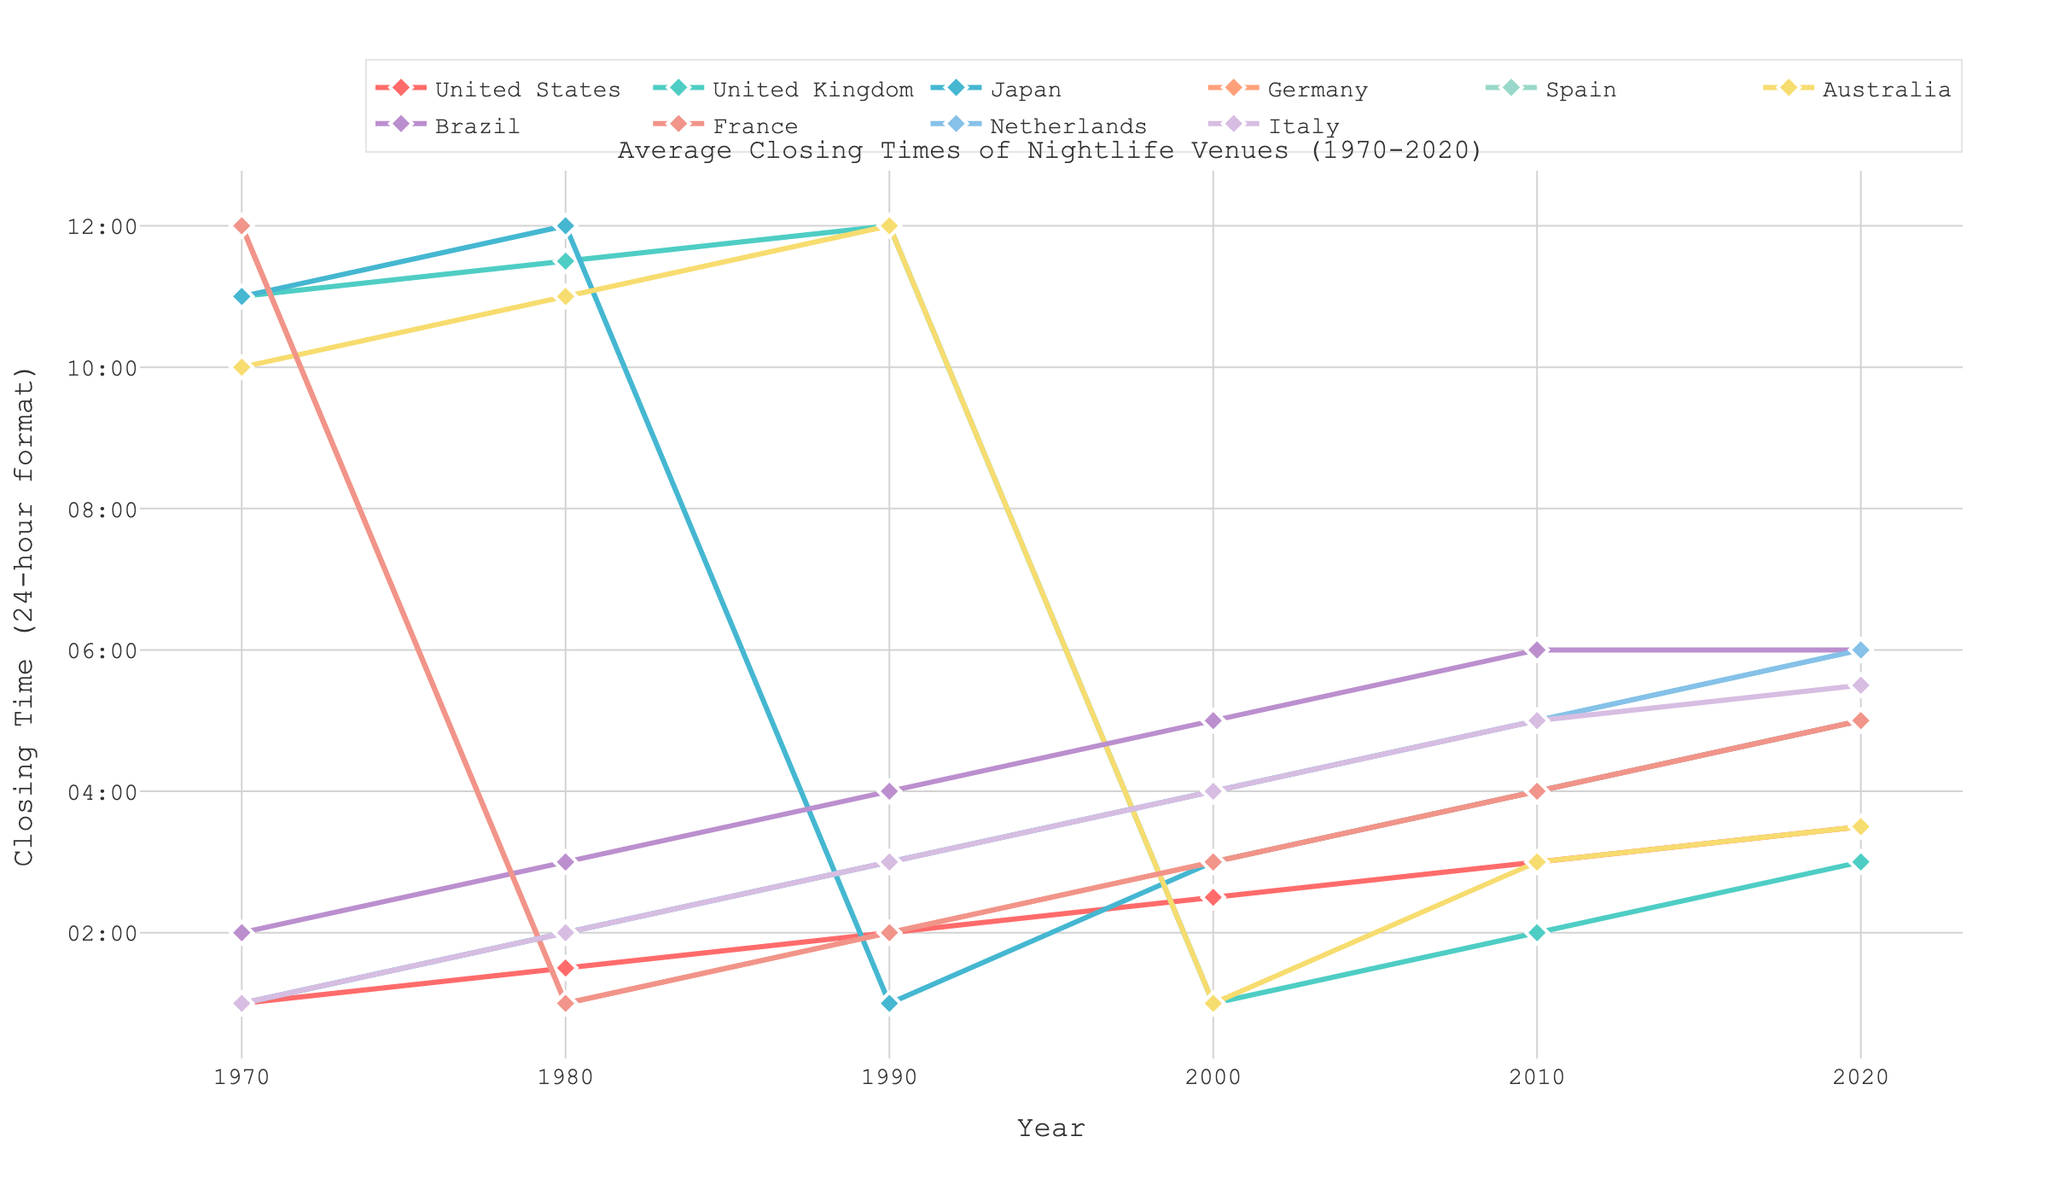Which country had the latest average closing time in 1970? The bar labeled 'Brazil' has a 2:00 closing time, which is the latest among all countries in 1970.
Answer: Brazil How much did the closing time change from 2000 to 2020 for the United States? The closing time for the United States was 2:30 in 2000 and 3:30 in 2020. The difference is 1 hour.
Answer: 1 hour Which country experienced the largest increase in closing times between 1970 and 2020? By visually comparing the length of the lines from 1970 to 2020, Japan saw an increase from 11:00 to 5:00, which is the largest increase of 6 hours.
Answer: Japan In 2020, which two countries had the same closing time, and what was that time? By looking at the lines for Brazil and Netherlands in 2020, both close at 6:00.
Answer: Brazil, Netherlands; 6:00 Which country showed the most significant difference in closing times between 1990 and 2000? Japan shows the most significant difference; from 1:00 to 3:00, which is an increase of 2 hours
Answer: Japan Which country had consistently increasing closing times every decade from 1970 to 2020? By examining the trends, the lines for Spain, Germany, and France show consistent increases every decade.
Answer: Spain, Germany, France In 1990, how much earlier did nightlife venues in the United Kingdom close compared to those in Italy? Nightlife venues in the United Kingdom closed at 12:00, whereas in Italy they closed at 3:00. The difference is 3 hours.
Answer: 3 hours What's the average closing time in 2020 across all countries? By summing (3:30, 3:00, 5:00, 5:00, 6:00, 3:30, 6:00, 5:00, 6:00, 5:30) and dividing by 10, we get the average closing time of 4:53.
Answer: 4:53 In which decade did nightlife venues in Australia have the smallest change in closing times? The closing times in Australia remained the same between 2010 and 2020 (3:00 to 3:30), a change of only 0.5 hours, which is the smallest change.
Answer: 2010-2020 Compare the closing times for the United States and Japan in both 1980 and 2020. How much did the difference change over these years? In 1980, the US closed at 1:30, and Japan at 12:00; a difference of 1.5 hours. In 2020, the US at 3:30, and Japan at 5:00; a difference of 1.5 hours. The difference remained the same.
Answer: No change 